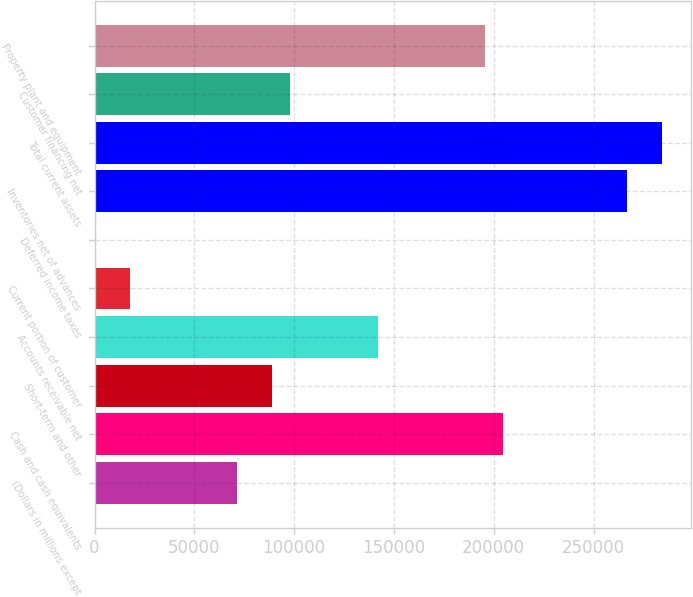Convert chart to OTSL. <chart><loc_0><loc_0><loc_500><loc_500><bar_chart><fcel>(Dollars in millions except<fcel>Cash and cash equivalents<fcel>Short-term and other<fcel>Accounts receivable net<fcel>Current portion of customer<fcel>Deferred income taxes<fcel>Inventories net of advances<fcel>Total current assets<fcel>Customer financing net<fcel>Property plant and equipment<nl><fcel>71122.4<fcel>204424<fcel>88896<fcel>142217<fcel>17801.6<fcel>28<fcel>266632<fcel>284406<fcel>97782.8<fcel>195538<nl></chart> 